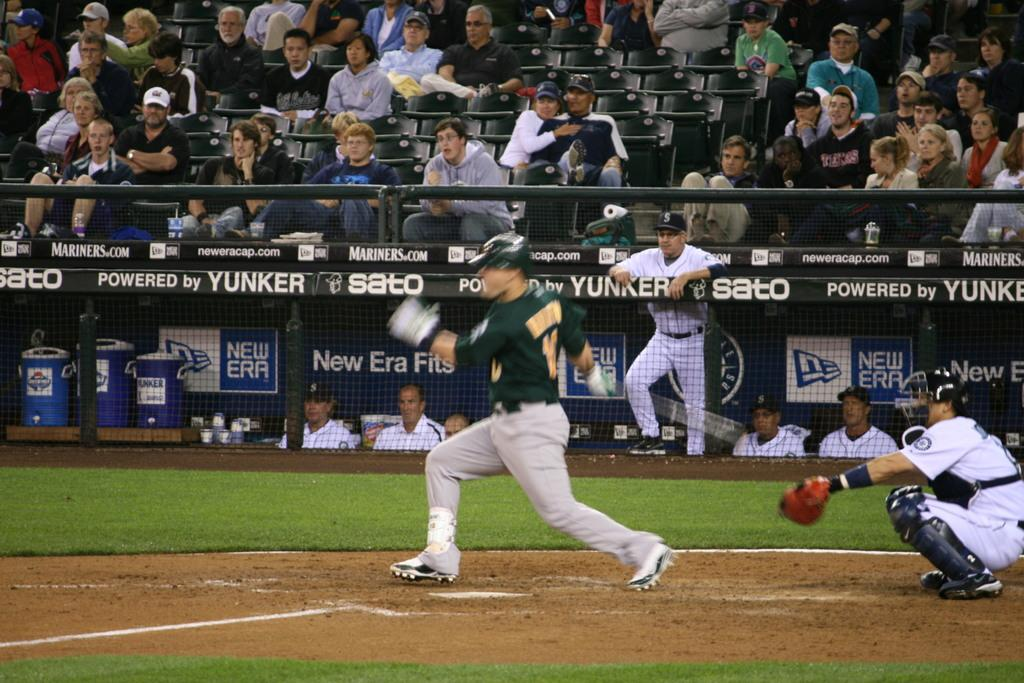<image>
Present a compact description of the photo's key features. A baseball player has swung for the ball and preparing to run and a sign is behind him that says New Era Fits. 